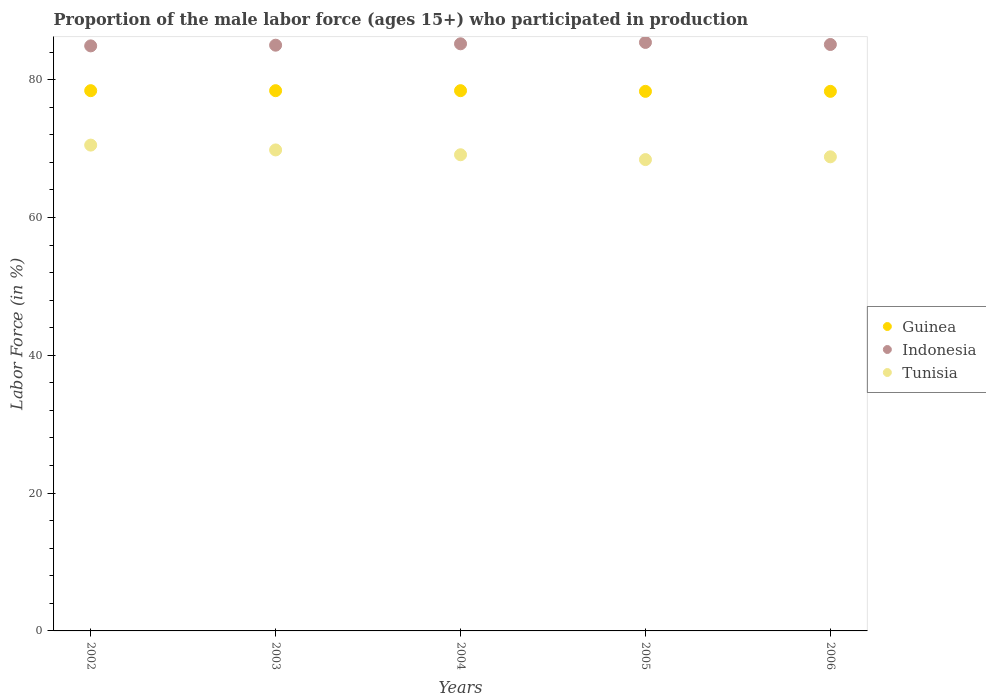What is the proportion of the male labor force who participated in production in Indonesia in 2002?
Offer a very short reply. 84.9. Across all years, what is the maximum proportion of the male labor force who participated in production in Indonesia?
Your answer should be compact. 85.4. Across all years, what is the minimum proportion of the male labor force who participated in production in Indonesia?
Ensure brevity in your answer.  84.9. In which year was the proportion of the male labor force who participated in production in Indonesia maximum?
Make the answer very short. 2005. What is the total proportion of the male labor force who participated in production in Tunisia in the graph?
Provide a short and direct response. 346.6. What is the difference between the proportion of the male labor force who participated in production in Guinea in 2004 and that in 2005?
Provide a succinct answer. 0.1. What is the difference between the proportion of the male labor force who participated in production in Guinea in 2004 and the proportion of the male labor force who participated in production in Indonesia in 2002?
Give a very brief answer. -6.5. What is the average proportion of the male labor force who participated in production in Guinea per year?
Your answer should be very brief. 78.36. In the year 2004, what is the difference between the proportion of the male labor force who participated in production in Tunisia and proportion of the male labor force who participated in production in Guinea?
Provide a succinct answer. -9.3. In how many years, is the proportion of the male labor force who participated in production in Indonesia greater than 52 %?
Your response must be concise. 5. What is the ratio of the proportion of the male labor force who participated in production in Indonesia in 2002 to that in 2005?
Offer a very short reply. 0.99. Is the difference between the proportion of the male labor force who participated in production in Tunisia in 2003 and 2006 greater than the difference between the proportion of the male labor force who participated in production in Guinea in 2003 and 2006?
Ensure brevity in your answer.  Yes. What is the difference between the highest and the second highest proportion of the male labor force who participated in production in Tunisia?
Your response must be concise. 0.7. Is the sum of the proportion of the male labor force who participated in production in Guinea in 2003 and 2004 greater than the maximum proportion of the male labor force who participated in production in Tunisia across all years?
Your answer should be very brief. Yes. Is the proportion of the male labor force who participated in production in Guinea strictly greater than the proportion of the male labor force who participated in production in Tunisia over the years?
Provide a short and direct response. Yes. How many dotlines are there?
Provide a succinct answer. 3. Does the graph contain any zero values?
Offer a terse response. No. How are the legend labels stacked?
Offer a terse response. Vertical. What is the title of the graph?
Offer a terse response. Proportion of the male labor force (ages 15+) who participated in production. What is the label or title of the X-axis?
Give a very brief answer. Years. What is the label or title of the Y-axis?
Your response must be concise. Labor Force (in %). What is the Labor Force (in %) in Guinea in 2002?
Your answer should be compact. 78.4. What is the Labor Force (in %) of Indonesia in 2002?
Your answer should be very brief. 84.9. What is the Labor Force (in %) of Tunisia in 2002?
Provide a succinct answer. 70.5. What is the Labor Force (in %) in Guinea in 2003?
Provide a short and direct response. 78.4. What is the Labor Force (in %) in Tunisia in 2003?
Ensure brevity in your answer.  69.8. What is the Labor Force (in %) of Guinea in 2004?
Offer a terse response. 78.4. What is the Labor Force (in %) in Indonesia in 2004?
Your answer should be compact. 85.2. What is the Labor Force (in %) of Tunisia in 2004?
Make the answer very short. 69.1. What is the Labor Force (in %) of Guinea in 2005?
Make the answer very short. 78.3. What is the Labor Force (in %) in Indonesia in 2005?
Ensure brevity in your answer.  85.4. What is the Labor Force (in %) of Tunisia in 2005?
Keep it short and to the point. 68.4. What is the Labor Force (in %) in Guinea in 2006?
Give a very brief answer. 78.3. What is the Labor Force (in %) in Indonesia in 2006?
Keep it short and to the point. 85.1. What is the Labor Force (in %) of Tunisia in 2006?
Your answer should be very brief. 68.8. Across all years, what is the maximum Labor Force (in %) of Guinea?
Make the answer very short. 78.4. Across all years, what is the maximum Labor Force (in %) in Indonesia?
Your response must be concise. 85.4. Across all years, what is the maximum Labor Force (in %) in Tunisia?
Ensure brevity in your answer.  70.5. Across all years, what is the minimum Labor Force (in %) in Guinea?
Offer a very short reply. 78.3. Across all years, what is the minimum Labor Force (in %) of Indonesia?
Your answer should be compact. 84.9. Across all years, what is the minimum Labor Force (in %) of Tunisia?
Ensure brevity in your answer.  68.4. What is the total Labor Force (in %) in Guinea in the graph?
Give a very brief answer. 391.8. What is the total Labor Force (in %) of Indonesia in the graph?
Your response must be concise. 425.6. What is the total Labor Force (in %) of Tunisia in the graph?
Keep it short and to the point. 346.6. What is the difference between the Labor Force (in %) in Guinea in 2002 and that in 2003?
Your response must be concise. 0. What is the difference between the Labor Force (in %) in Guinea in 2002 and that in 2004?
Ensure brevity in your answer.  0. What is the difference between the Labor Force (in %) of Indonesia in 2002 and that in 2004?
Ensure brevity in your answer.  -0.3. What is the difference between the Labor Force (in %) in Tunisia in 2002 and that in 2004?
Offer a terse response. 1.4. What is the difference between the Labor Force (in %) in Guinea in 2002 and that in 2005?
Keep it short and to the point. 0.1. What is the difference between the Labor Force (in %) in Indonesia in 2002 and that in 2005?
Make the answer very short. -0.5. What is the difference between the Labor Force (in %) of Tunisia in 2002 and that in 2005?
Give a very brief answer. 2.1. What is the difference between the Labor Force (in %) of Guinea in 2002 and that in 2006?
Offer a very short reply. 0.1. What is the difference between the Labor Force (in %) of Indonesia in 2002 and that in 2006?
Your answer should be very brief. -0.2. What is the difference between the Labor Force (in %) in Guinea in 2003 and that in 2004?
Keep it short and to the point. 0. What is the difference between the Labor Force (in %) of Indonesia in 2003 and that in 2005?
Provide a short and direct response. -0.4. What is the difference between the Labor Force (in %) of Indonesia in 2003 and that in 2006?
Keep it short and to the point. -0.1. What is the difference between the Labor Force (in %) in Guinea in 2004 and that in 2005?
Your response must be concise. 0.1. What is the difference between the Labor Force (in %) in Guinea in 2004 and that in 2006?
Your answer should be very brief. 0.1. What is the difference between the Labor Force (in %) of Indonesia in 2004 and that in 2006?
Provide a short and direct response. 0.1. What is the difference between the Labor Force (in %) in Guinea in 2005 and that in 2006?
Your answer should be compact. 0. What is the difference between the Labor Force (in %) in Tunisia in 2005 and that in 2006?
Keep it short and to the point. -0.4. What is the difference between the Labor Force (in %) of Guinea in 2002 and the Labor Force (in %) of Indonesia in 2003?
Keep it short and to the point. -6.6. What is the difference between the Labor Force (in %) in Guinea in 2002 and the Labor Force (in %) in Tunisia in 2003?
Provide a succinct answer. 8.6. What is the difference between the Labor Force (in %) of Indonesia in 2002 and the Labor Force (in %) of Tunisia in 2003?
Give a very brief answer. 15.1. What is the difference between the Labor Force (in %) in Indonesia in 2002 and the Labor Force (in %) in Tunisia in 2004?
Your answer should be very brief. 15.8. What is the difference between the Labor Force (in %) of Guinea in 2002 and the Labor Force (in %) of Indonesia in 2005?
Give a very brief answer. -7. What is the difference between the Labor Force (in %) in Indonesia in 2002 and the Labor Force (in %) in Tunisia in 2005?
Keep it short and to the point. 16.5. What is the difference between the Labor Force (in %) in Guinea in 2002 and the Labor Force (in %) in Indonesia in 2006?
Provide a short and direct response. -6.7. What is the difference between the Labor Force (in %) in Guinea in 2003 and the Labor Force (in %) in Indonesia in 2004?
Give a very brief answer. -6.8. What is the difference between the Labor Force (in %) in Guinea in 2003 and the Labor Force (in %) in Tunisia in 2004?
Offer a very short reply. 9.3. What is the difference between the Labor Force (in %) of Indonesia in 2003 and the Labor Force (in %) of Tunisia in 2004?
Provide a short and direct response. 15.9. What is the difference between the Labor Force (in %) in Guinea in 2003 and the Labor Force (in %) in Indonesia in 2005?
Keep it short and to the point. -7. What is the difference between the Labor Force (in %) in Guinea in 2003 and the Labor Force (in %) in Tunisia in 2005?
Make the answer very short. 10. What is the difference between the Labor Force (in %) of Indonesia in 2003 and the Labor Force (in %) of Tunisia in 2006?
Offer a terse response. 16.2. What is the difference between the Labor Force (in %) of Indonesia in 2004 and the Labor Force (in %) of Tunisia in 2005?
Your answer should be very brief. 16.8. What is the difference between the Labor Force (in %) in Guinea in 2005 and the Labor Force (in %) in Indonesia in 2006?
Provide a succinct answer. -6.8. What is the difference between the Labor Force (in %) in Guinea in 2005 and the Labor Force (in %) in Tunisia in 2006?
Your answer should be very brief. 9.5. What is the average Labor Force (in %) in Guinea per year?
Offer a terse response. 78.36. What is the average Labor Force (in %) of Indonesia per year?
Keep it short and to the point. 85.12. What is the average Labor Force (in %) of Tunisia per year?
Keep it short and to the point. 69.32. In the year 2002, what is the difference between the Labor Force (in %) in Guinea and Labor Force (in %) in Indonesia?
Provide a short and direct response. -6.5. In the year 2002, what is the difference between the Labor Force (in %) in Indonesia and Labor Force (in %) in Tunisia?
Offer a very short reply. 14.4. In the year 2003, what is the difference between the Labor Force (in %) in Guinea and Labor Force (in %) in Tunisia?
Give a very brief answer. 8.6. In the year 2003, what is the difference between the Labor Force (in %) of Indonesia and Labor Force (in %) of Tunisia?
Ensure brevity in your answer.  15.2. In the year 2004, what is the difference between the Labor Force (in %) of Guinea and Labor Force (in %) of Tunisia?
Your answer should be compact. 9.3. In the year 2004, what is the difference between the Labor Force (in %) in Indonesia and Labor Force (in %) in Tunisia?
Your answer should be very brief. 16.1. In the year 2005, what is the difference between the Labor Force (in %) in Guinea and Labor Force (in %) in Indonesia?
Make the answer very short. -7.1. In the year 2005, what is the difference between the Labor Force (in %) in Guinea and Labor Force (in %) in Tunisia?
Provide a succinct answer. 9.9. In the year 2005, what is the difference between the Labor Force (in %) of Indonesia and Labor Force (in %) of Tunisia?
Ensure brevity in your answer.  17. In the year 2006, what is the difference between the Labor Force (in %) of Guinea and Labor Force (in %) of Tunisia?
Provide a short and direct response. 9.5. In the year 2006, what is the difference between the Labor Force (in %) of Indonesia and Labor Force (in %) of Tunisia?
Provide a succinct answer. 16.3. What is the ratio of the Labor Force (in %) of Indonesia in 2002 to that in 2003?
Your answer should be very brief. 1. What is the ratio of the Labor Force (in %) of Tunisia in 2002 to that in 2004?
Offer a terse response. 1.02. What is the ratio of the Labor Force (in %) in Tunisia in 2002 to that in 2005?
Offer a terse response. 1.03. What is the ratio of the Labor Force (in %) in Indonesia in 2002 to that in 2006?
Your answer should be compact. 1. What is the ratio of the Labor Force (in %) in Tunisia in 2002 to that in 2006?
Make the answer very short. 1.02. What is the ratio of the Labor Force (in %) in Guinea in 2003 to that in 2004?
Give a very brief answer. 1. What is the ratio of the Labor Force (in %) in Guinea in 2003 to that in 2005?
Make the answer very short. 1. What is the ratio of the Labor Force (in %) in Indonesia in 2003 to that in 2005?
Ensure brevity in your answer.  1. What is the ratio of the Labor Force (in %) of Tunisia in 2003 to that in 2005?
Provide a succinct answer. 1.02. What is the ratio of the Labor Force (in %) of Guinea in 2003 to that in 2006?
Offer a terse response. 1. What is the ratio of the Labor Force (in %) of Tunisia in 2003 to that in 2006?
Keep it short and to the point. 1.01. What is the ratio of the Labor Force (in %) of Guinea in 2004 to that in 2005?
Make the answer very short. 1. What is the ratio of the Labor Force (in %) in Tunisia in 2004 to that in 2005?
Offer a terse response. 1.01. What is the ratio of the Labor Force (in %) in Indonesia in 2005 to that in 2006?
Ensure brevity in your answer.  1. What is the difference between the highest and the second highest Labor Force (in %) in Guinea?
Make the answer very short. 0. What is the difference between the highest and the second highest Labor Force (in %) of Tunisia?
Keep it short and to the point. 0.7. What is the difference between the highest and the lowest Labor Force (in %) in Indonesia?
Offer a very short reply. 0.5. What is the difference between the highest and the lowest Labor Force (in %) in Tunisia?
Keep it short and to the point. 2.1. 